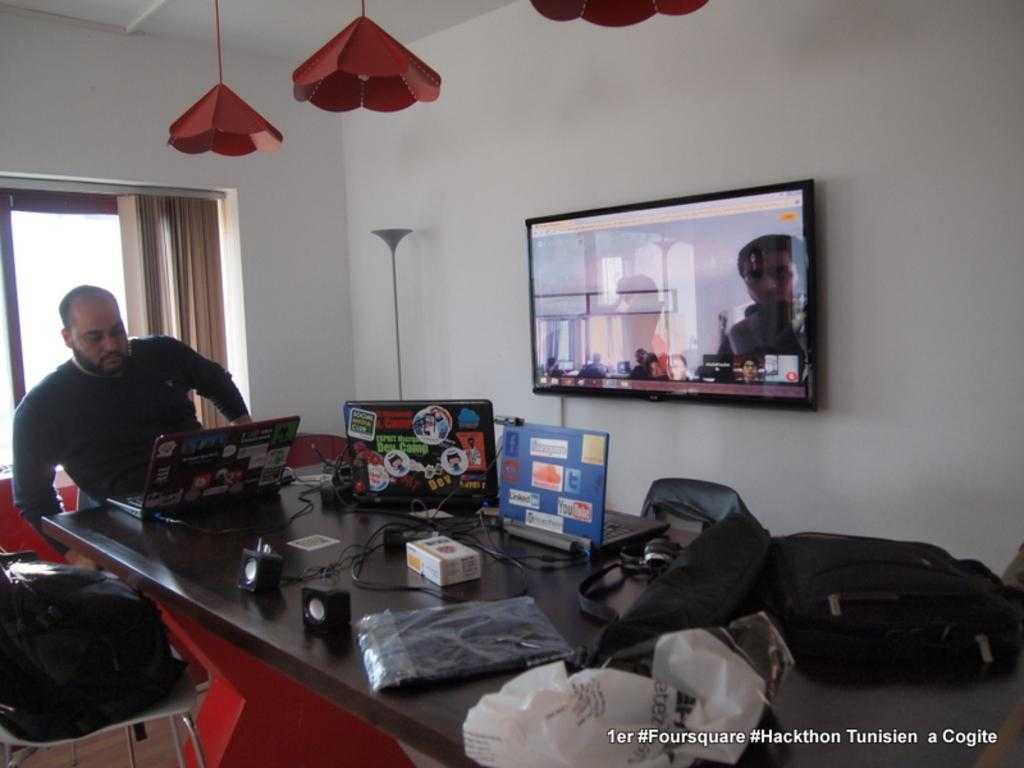What is the color of the wall in the image? The wall in the image is white. What is located near the wall? There is a window with a curtain in the image. What is present on the table in the image? There is a camera, covers, banners, and laptops on the table in the image. What is the man in the image doing? The man is sitting on a chair in the image. What is the purpose of the screen in the image? The purpose of the screen is not specified in the provided facts. What type of basket is hanging on the wall in the image? There is no basket present on the wall in the image. What material is the brass used for in the image? There is no brass present in the image. 